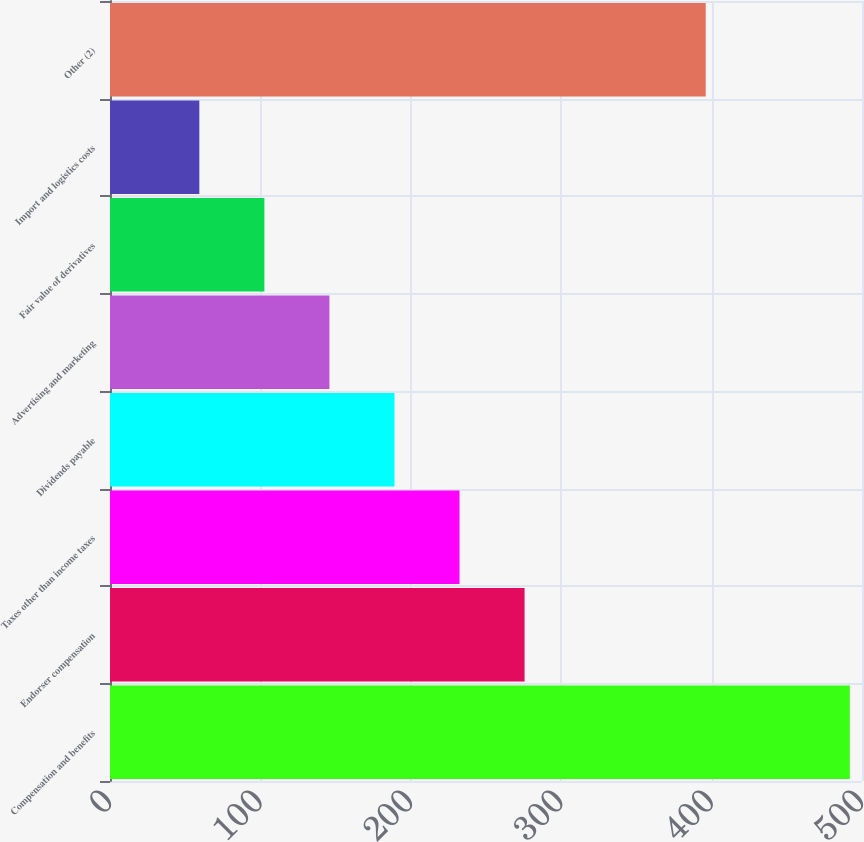Convert chart. <chart><loc_0><loc_0><loc_500><loc_500><bar_chart><fcel>Compensation and benefits<fcel>Endorser compensation<fcel>Taxes other than income taxes<fcel>Dividends payable<fcel>Advertising and marketing<fcel>Fair value of derivatives<fcel>Import and logistics costs<fcel>Other (2)<nl><fcel>491.9<fcel>275.65<fcel>232.4<fcel>189.15<fcel>145.9<fcel>102.65<fcel>59.4<fcel>396.1<nl></chart> 